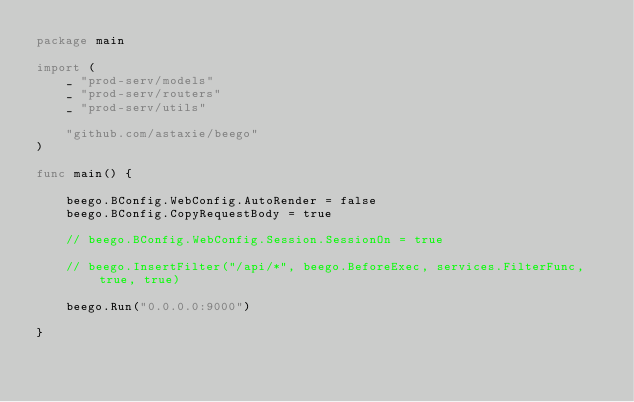Convert code to text. <code><loc_0><loc_0><loc_500><loc_500><_Go_>package main

import (
	_ "prod-serv/models"
	_ "prod-serv/routers"
	_ "prod-serv/utils"

	"github.com/astaxie/beego"
)

func main() {

	beego.BConfig.WebConfig.AutoRender = false
	beego.BConfig.CopyRequestBody = true

	// beego.BConfig.WebConfig.Session.SessionOn = true

	// beego.InsertFilter("/api/*", beego.BeforeExec, services.FilterFunc, true, true)

	beego.Run("0.0.0.0:9000")

}
</code> 